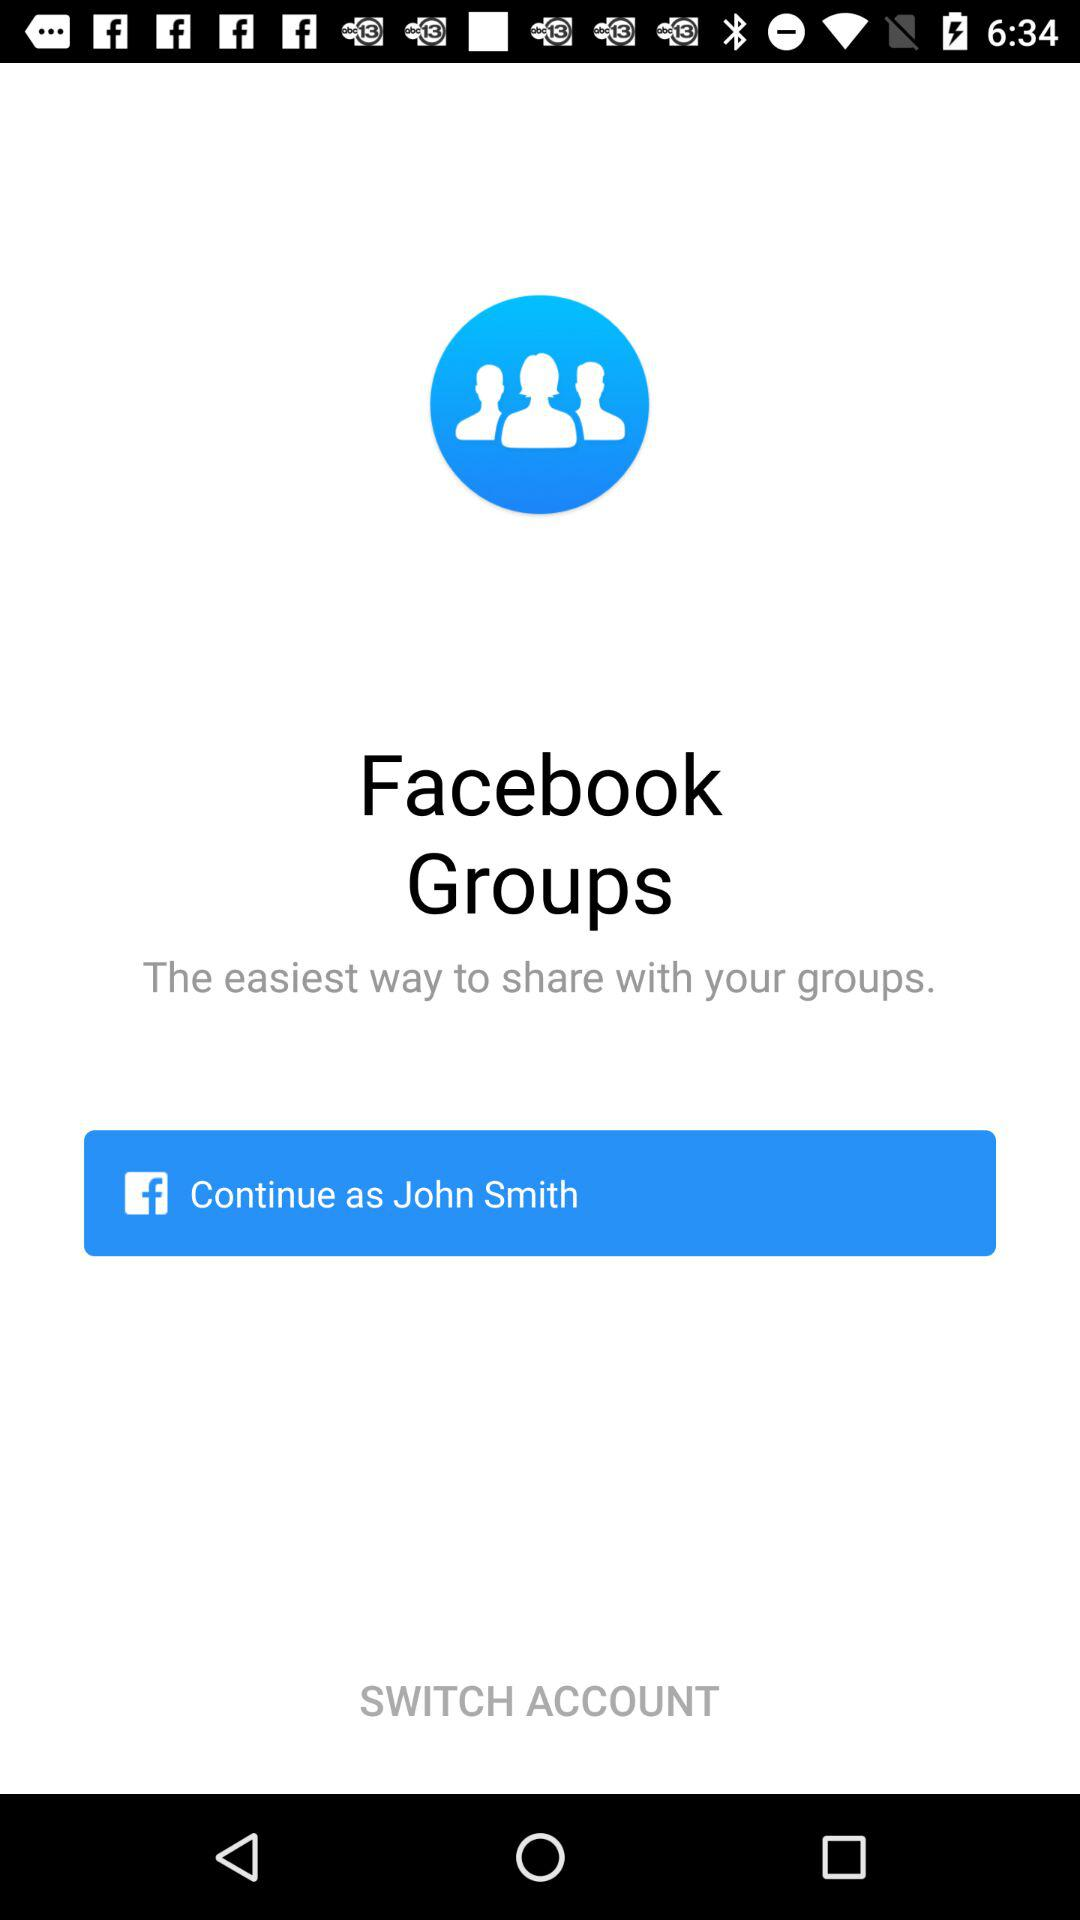What is the name of the user? The name of the user is John Smith. 